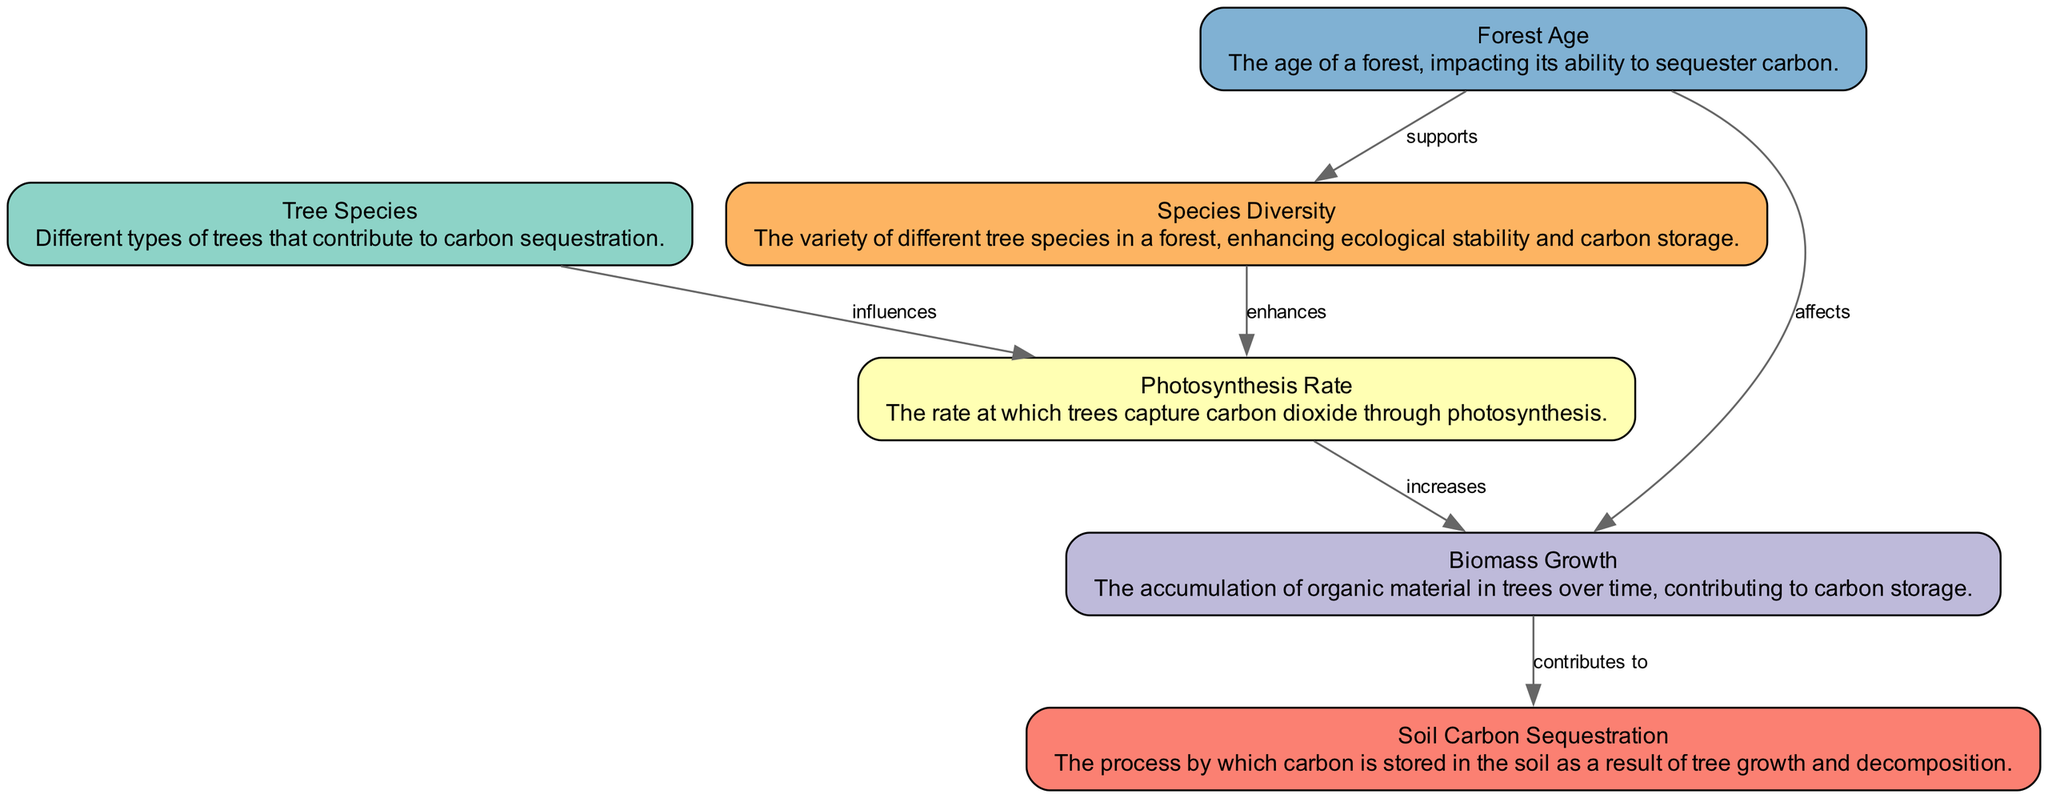What is the label of the node that describes the accumulation of organic material in trees? The node 'Biomass' has the label "Biomass Growth", which describes the accumulation of organic material in trees over time, contributing to carbon storage.
Answer: Biomass Growth How many edges are present in the diagram? By counting the connections between the nodes (or edges defined in the data), there are a total of 6 edges that illustrate the relationships between nodes.
Answer: 6 Which tree species-related node influences the photosynthesis rate? The edge from 'TreeSpecies' to 'Photosynthesis' indicates that different tree species influence the photosynthesis rate, which is represented in the diagram.
Answer: Tree Species What relationship supports species diversity within forest ecosystems? The edge between 'ForestAge' and 'SpeciesDiversity' shows that the age of the forest supports species diversity, as per the relationships depicted in the diagram.
Answer: supports Which node is affected by the forest age? There are two edges stemming from 'ForestAge', one leading to 'Biomass' and the other promoting 'SpeciesDiversity', indicating that forest age affects both biomass growth and species diversity.
Answer: Biomass and Species Diversity How does high species diversity impact carbon sequestration? The diagram shows that 'Species Diversity' enhances the 'Photosynthesis' rate, which in turn leads to an increase in carbon sequestration, demonstrating a positive feedback loop in the relationships.
Answer: enhances What is the main contributor to soil carbon according to the diagram? The edge from 'Biomass' to 'SoilCarbon' indicates that biomass growth contributes to soil carbon sequestration, establishing it as the main contributor in the diagram.
Answer: Biomass What is the direct influence of photosynthesis on carbon storage? The 'Photosynthesis' node has a direct effect on 'Biomass', where the increase in the photosynthesis rate results in higher biomass accumulation, directly contributing to carbon storage.
Answer: increases Which node is influenced by both photosynthesis and biomass? The 'Biomass' node is influenced by 'Photosynthesis', and it also contributes to 'SoilCarbon', establishing a connection between these factors within the carbon storage ecosystem.
Answer: Biomass 